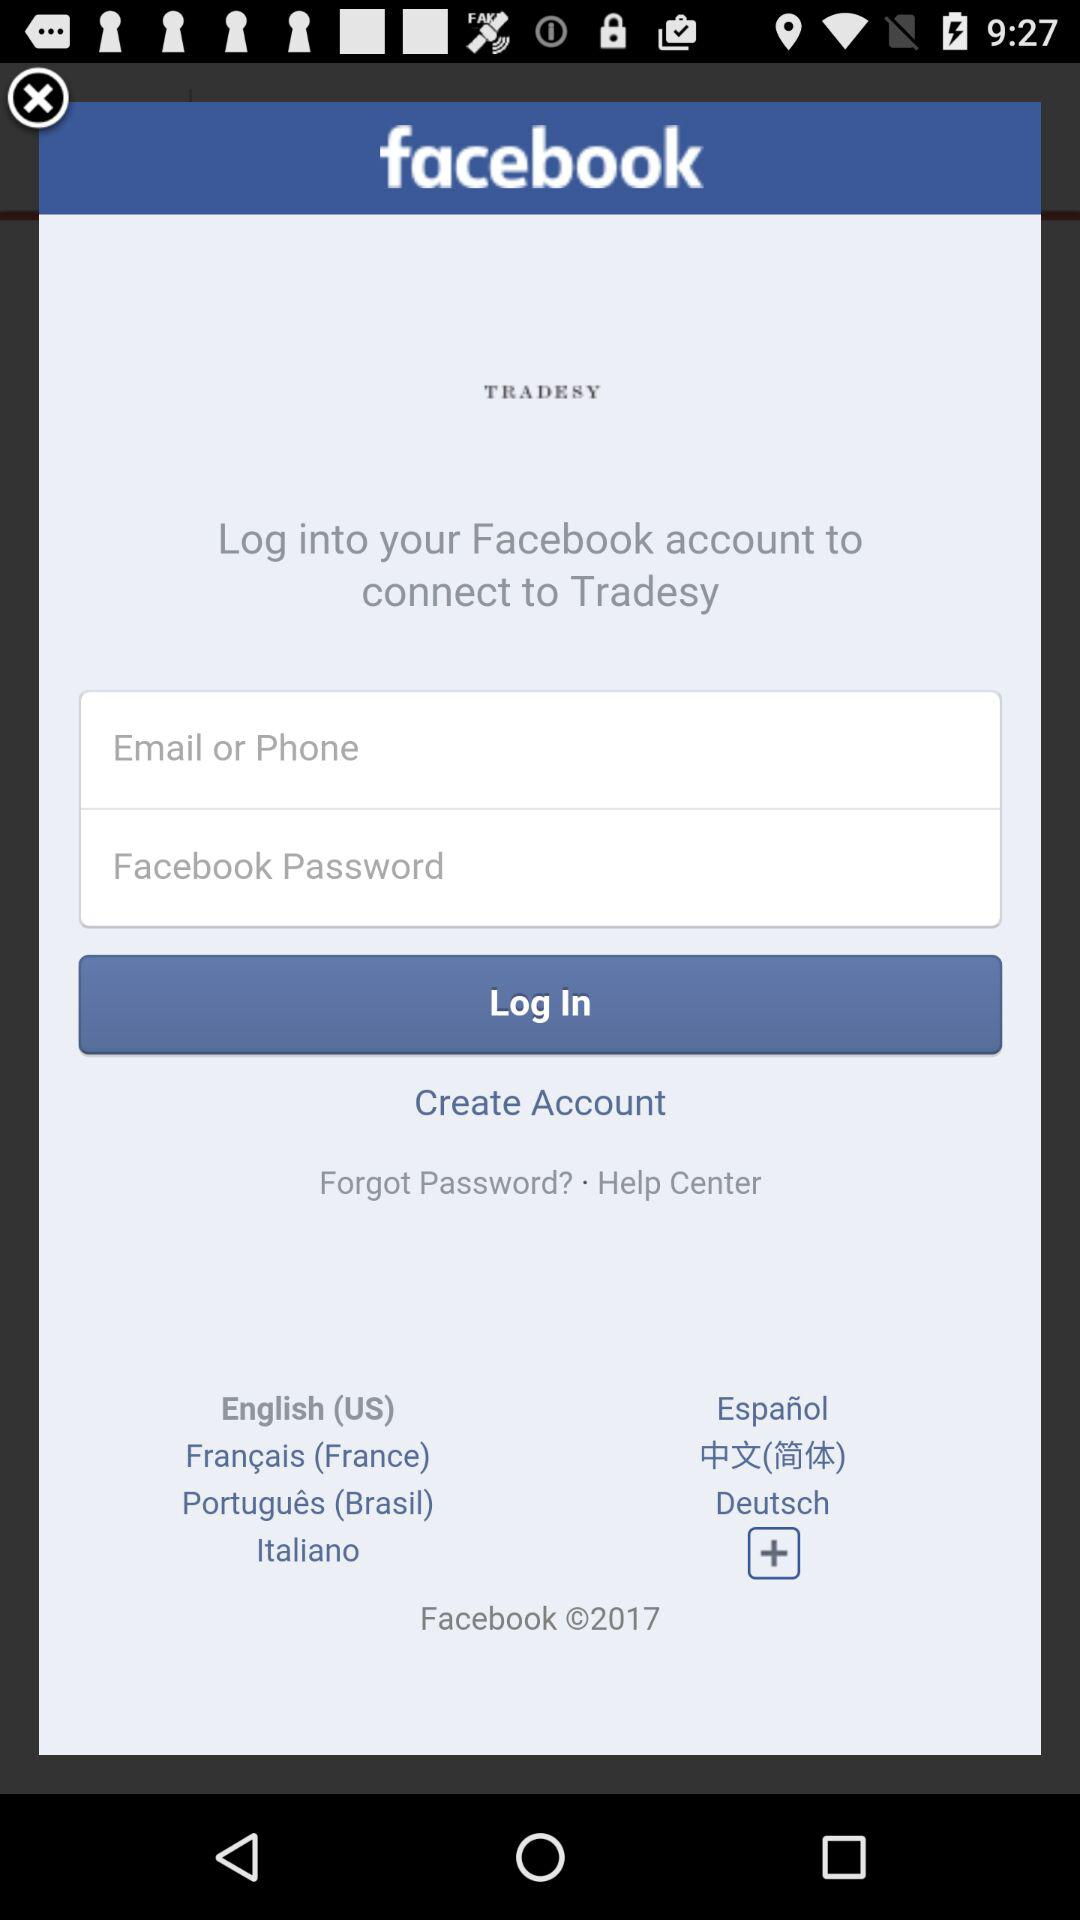What is the entered phone number?
When the provided information is insufficient, respond with <no answer>. <no answer> 